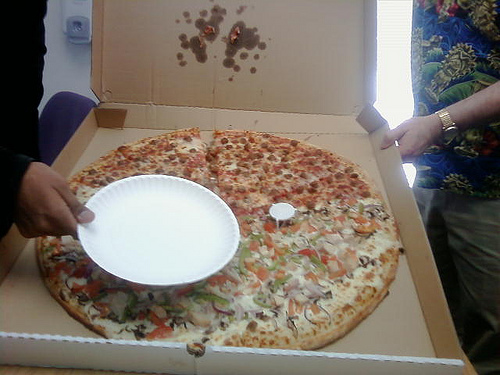<image>What is in the white cup? There is no white cup in the image. What is in the white cup? There is no white cup in the image. 